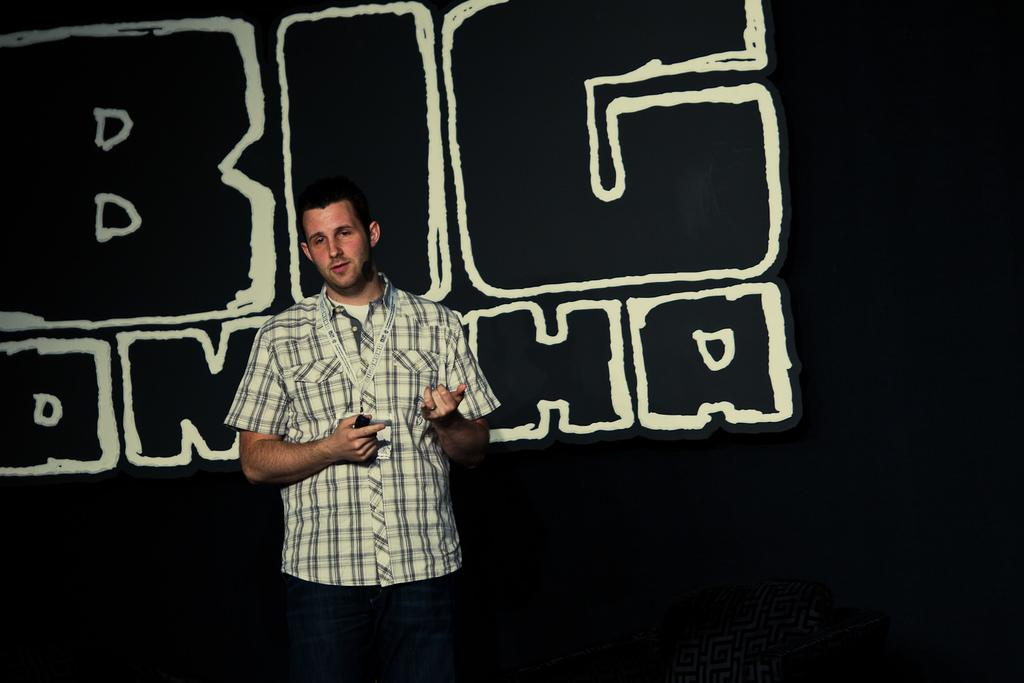What is the main subject of the image? There is a person in the image. What can be observed about the background of the image? The background of the image is dark. What else is present in the image besides the person? There is text in the middle of the image. How many ants can be seen crawling on the person in the image? There are no ants present in the image. What type of stew is being served in the image? There is no stew present in the image. 